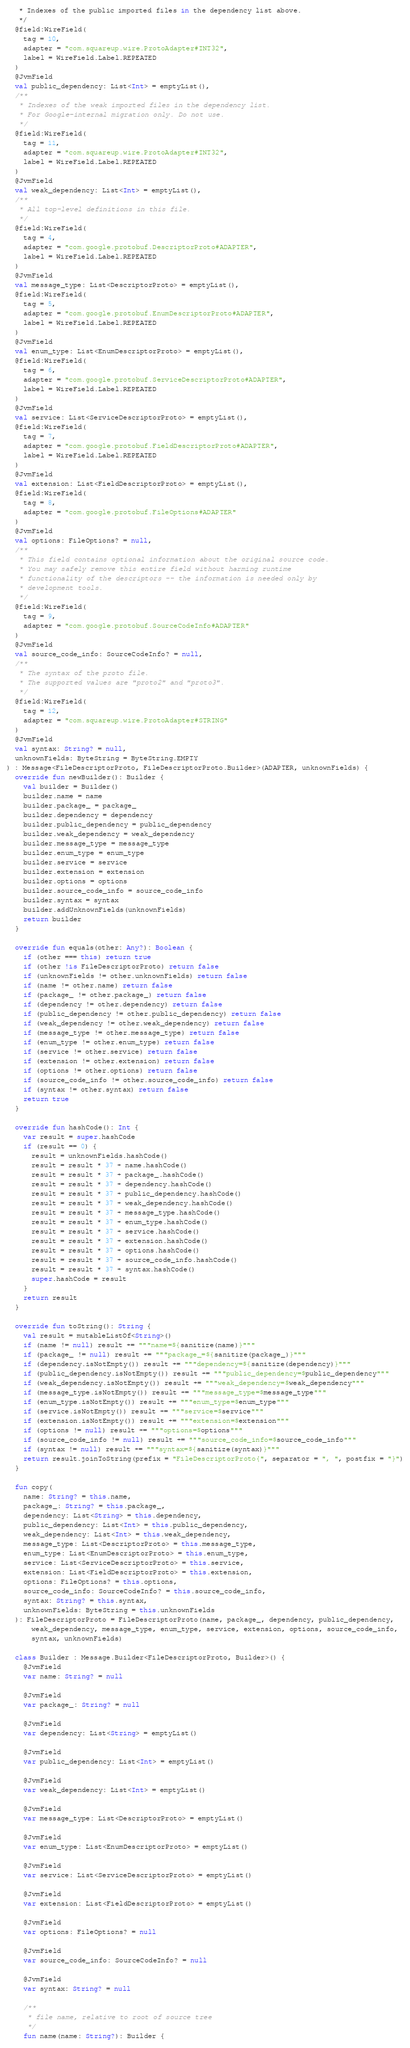Convert code to text. <code><loc_0><loc_0><loc_500><loc_500><_Kotlin_>   * Indexes of the public imported files in the dependency list above.
   */
  @field:WireField(
    tag = 10,
    adapter = "com.squareup.wire.ProtoAdapter#INT32",
    label = WireField.Label.REPEATED
  )
  @JvmField
  val public_dependency: List<Int> = emptyList(),
  /**
   * Indexes of the weak imported files in the dependency list.
   * For Google-internal migration only. Do not use.
   */
  @field:WireField(
    tag = 11,
    adapter = "com.squareup.wire.ProtoAdapter#INT32",
    label = WireField.Label.REPEATED
  )
  @JvmField
  val weak_dependency: List<Int> = emptyList(),
  /**
   * All top-level definitions in this file.
   */
  @field:WireField(
    tag = 4,
    adapter = "com.google.protobuf.DescriptorProto#ADAPTER",
    label = WireField.Label.REPEATED
  )
  @JvmField
  val message_type: List<DescriptorProto> = emptyList(),
  @field:WireField(
    tag = 5,
    adapter = "com.google.protobuf.EnumDescriptorProto#ADAPTER",
    label = WireField.Label.REPEATED
  )
  @JvmField
  val enum_type: List<EnumDescriptorProto> = emptyList(),
  @field:WireField(
    tag = 6,
    adapter = "com.google.protobuf.ServiceDescriptorProto#ADAPTER",
    label = WireField.Label.REPEATED
  )
  @JvmField
  val service: List<ServiceDescriptorProto> = emptyList(),
  @field:WireField(
    tag = 7,
    adapter = "com.google.protobuf.FieldDescriptorProto#ADAPTER",
    label = WireField.Label.REPEATED
  )
  @JvmField
  val extension: List<FieldDescriptorProto> = emptyList(),
  @field:WireField(
    tag = 8,
    adapter = "com.google.protobuf.FileOptions#ADAPTER"
  )
  @JvmField
  val options: FileOptions? = null,
  /**
   * This field contains optional information about the original source code.
   * You may safely remove this entire field without harming runtime
   * functionality of the descriptors -- the information is needed only by
   * development tools.
   */
  @field:WireField(
    tag = 9,
    adapter = "com.google.protobuf.SourceCodeInfo#ADAPTER"
  )
  @JvmField
  val source_code_info: SourceCodeInfo? = null,
  /**
   * The syntax of the proto file.
   * The supported values are "proto2" and "proto3".
   */
  @field:WireField(
    tag = 12,
    adapter = "com.squareup.wire.ProtoAdapter#STRING"
  )
  @JvmField
  val syntax: String? = null,
  unknownFields: ByteString = ByteString.EMPTY
) : Message<FileDescriptorProto, FileDescriptorProto.Builder>(ADAPTER, unknownFields) {
  override fun newBuilder(): Builder {
    val builder = Builder()
    builder.name = name
    builder.package_ = package_
    builder.dependency = dependency
    builder.public_dependency = public_dependency
    builder.weak_dependency = weak_dependency
    builder.message_type = message_type
    builder.enum_type = enum_type
    builder.service = service
    builder.extension = extension
    builder.options = options
    builder.source_code_info = source_code_info
    builder.syntax = syntax
    builder.addUnknownFields(unknownFields)
    return builder
  }

  override fun equals(other: Any?): Boolean {
    if (other === this) return true
    if (other !is FileDescriptorProto) return false
    if (unknownFields != other.unknownFields) return false
    if (name != other.name) return false
    if (package_ != other.package_) return false
    if (dependency != other.dependency) return false
    if (public_dependency != other.public_dependency) return false
    if (weak_dependency != other.weak_dependency) return false
    if (message_type != other.message_type) return false
    if (enum_type != other.enum_type) return false
    if (service != other.service) return false
    if (extension != other.extension) return false
    if (options != other.options) return false
    if (source_code_info != other.source_code_info) return false
    if (syntax != other.syntax) return false
    return true
  }

  override fun hashCode(): Int {
    var result = super.hashCode
    if (result == 0) {
      result = unknownFields.hashCode()
      result = result * 37 + name.hashCode()
      result = result * 37 + package_.hashCode()
      result = result * 37 + dependency.hashCode()
      result = result * 37 + public_dependency.hashCode()
      result = result * 37 + weak_dependency.hashCode()
      result = result * 37 + message_type.hashCode()
      result = result * 37 + enum_type.hashCode()
      result = result * 37 + service.hashCode()
      result = result * 37 + extension.hashCode()
      result = result * 37 + options.hashCode()
      result = result * 37 + source_code_info.hashCode()
      result = result * 37 + syntax.hashCode()
      super.hashCode = result
    }
    return result
  }

  override fun toString(): String {
    val result = mutableListOf<String>()
    if (name != null) result += """name=${sanitize(name)}"""
    if (package_ != null) result += """package_=${sanitize(package_)}"""
    if (dependency.isNotEmpty()) result += """dependency=${sanitize(dependency)}"""
    if (public_dependency.isNotEmpty()) result += """public_dependency=$public_dependency"""
    if (weak_dependency.isNotEmpty()) result += """weak_dependency=$weak_dependency"""
    if (message_type.isNotEmpty()) result += """message_type=$message_type"""
    if (enum_type.isNotEmpty()) result += """enum_type=$enum_type"""
    if (service.isNotEmpty()) result += """service=$service"""
    if (extension.isNotEmpty()) result += """extension=$extension"""
    if (options != null) result += """options=$options"""
    if (source_code_info != null) result += """source_code_info=$source_code_info"""
    if (syntax != null) result += """syntax=${sanitize(syntax)}"""
    return result.joinToString(prefix = "FileDescriptorProto{", separator = ", ", postfix = "}")
  }

  fun copy(
    name: String? = this.name,
    package_: String? = this.package_,
    dependency: List<String> = this.dependency,
    public_dependency: List<Int> = this.public_dependency,
    weak_dependency: List<Int> = this.weak_dependency,
    message_type: List<DescriptorProto> = this.message_type,
    enum_type: List<EnumDescriptorProto> = this.enum_type,
    service: List<ServiceDescriptorProto> = this.service,
    extension: List<FieldDescriptorProto> = this.extension,
    options: FileOptions? = this.options,
    source_code_info: SourceCodeInfo? = this.source_code_info,
    syntax: String? = this.syntax,
    unknownFields: ByteString = this.unknownFields
  ): FileDescriptorProto = FileDescriptorProto(name, package_, dependency, public_dependency,
      weak_dependency, message_type, enum_type, service, extension, options, source_code_info,
      syntax, unknownFields)

  class Builder : Message.Builder<FileDescriptorProto, Builder>() {
    @JvmField
    var name: String? = null

    @JvmField
    var package_: String? = null

    @JvmField
    var dependency: List<String> = emptyList()

    @JvmField
    var public_dependency: List<Int> = emptyList()

    @JvmField
    var weak_dependency: List<Int> = emptyList()

    @JvmField
    var message_type: List<DescriptorProto> = emptyList()

    @JvmField
    var enum_type: List<EnumDescriptorProto> = emptyList()

    @JvmField
    var service: List<ServiceDescriptorProto> = emptyList()

    @JvmField
    var extension: List<FieldDescriptorProto> = emptyList()

    @JvmField
    var options: FileOptions? = null

    @JvmField
    var source_code_info: SourceCodeInfo? = null

    @JvmField
    var syntax: String? = null

    /**
     * file name, relative to root of source tree
     */
    fun name(name: String?): Builder {</code> 